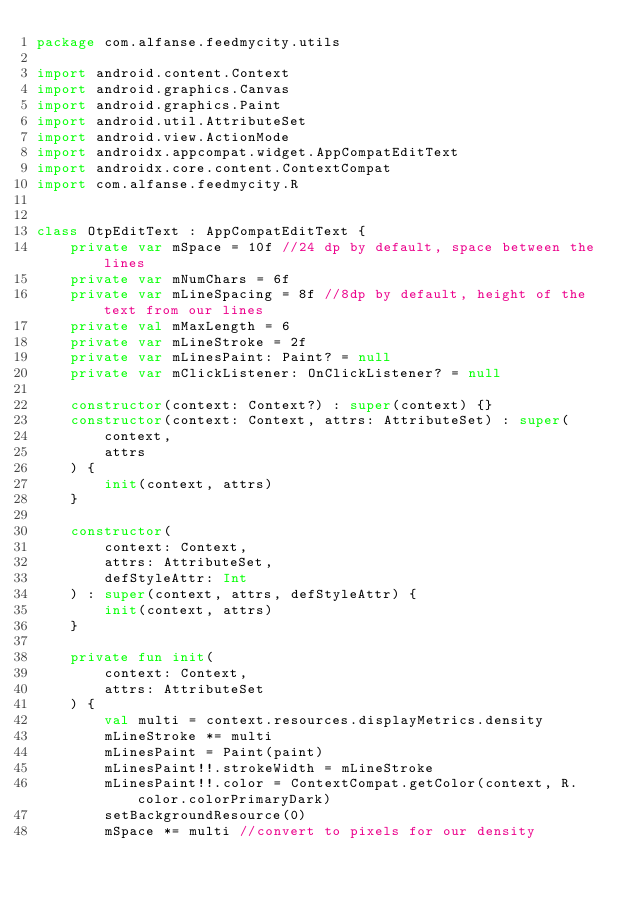Convert code to text. <code><loc_0><loc_0><loc_500><loc_500><_Kotlin_>package com.alfanse.feedmycity.utils

import android.content.Context
import android.graphics.Canvas
import android.graphics.Paint
import android.util.AttributeSet
import android.view.ActionMode
import androidx.appcompat.widget.AppCompatEditText
import androidx.core.content.ContextCompat
import com.alfanse.feedmycity.R


class OtpEditText : AppCompatEditText {
    private var mSpace = 10f //24 dp by default, space between the lines
    private var mNumChars = 6f
    private var mLineSpacing = 8f //8dp by default, height of the text from our lines
    private val mMaxLength = 6
    private var mLineStroke = 2f
    private var mLinesPaint: Paint? = null
    private var mClickListener: OnClickListener? = null

    constructor(context: Context?) : super(context) {}
    constructor(context: Context, attrs: AttributeSet) : super(
        context,
        attrs
    ) {
        init(context, attrs)
    }

    constructor(
        context: Context,
        attrs: AttributeSet,
        defStyleAttr: Int
    ) : super(context, attrs, defStyleAttr) {
        init(context, attrs)
    }

    private fun init(
        context: Context,
        attrs: AttributeSet
    ) {
        val multi = context.resources.displayMetrics.density
        mLineStroke *= multi
        mLinesPaint = Paint(paint)
        mLinesPaint!!.strokeWidth = mLineStroke
        mLinesPaint!!.color = ContextCompat.getColor(context, R.color.colorPrimaryDark)
        setBackgroundResource(0)
        mSpace *= multi //convert to pixels for our density</code> 